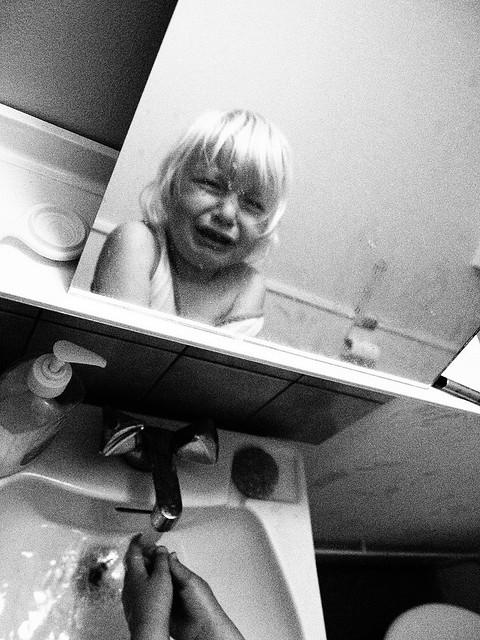Unhappy little person seen in reflected glass?
Be succinct. Yes. What color is the photo?
Keep it brief. Black and white. Is she smiling?
Write a very short answer. No. 